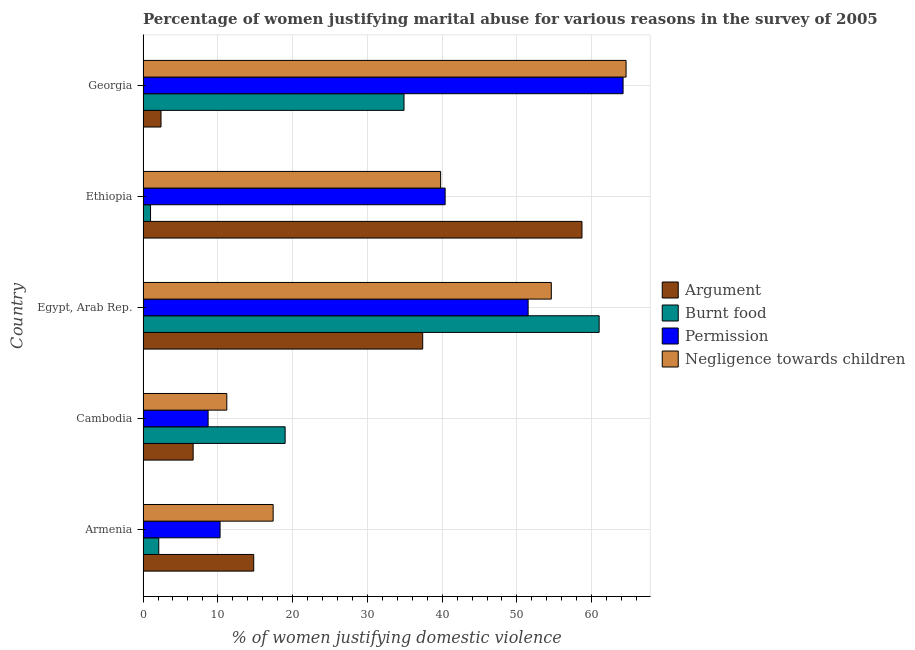How many different coloured bars are there?
Offer a very short reply. 4. What is the label of the 3rd group of bars from the top?
Make the answer very short. Egypt, Arab Rep. In how many cases, is the number of bars for a given country not equal to the number of legend labels?
Provide a succinct answer. 0. What is the percentage of women justifying abuse for showing negligence towards children in Ethiopia?
Offer a terse response. 39.8. Across all countries, what is the maximum percentage of women justifying abuse in the case of an argument?
Your response must be concise. 58.7. In which country was the percentage of women justifying abuse for going without permission maximum?
Provide a succinct answer. Georgia. In which country was the percentage of women justifying abuse in the case of an argument minimum?
Provide a short and direct response. Georgia. What is the total percentage of women justifying abuse for burning food in the graph?
Give a very brief answer. 118. What is the difference between the percentage of women justifying abuse for burning food in Armenia and that in Egypt, Arab Rep.?
Offer a terse response. -58.9. What is the difference between the percentage of women justifying abuse for showing negligence towards children in Ethiopia and the percentage of women justifying abuse in the case of an argument in Armenia?
Offer a terse response. 25. What is the average percentage of women justifying abuse for showing negligence towards children per country?
Provide a succinct answer. 37.52. What is the difference between the percentage of women justifying abuse for showing negligence towards children and percentage of women justifying abuse for going without permission in Cambodia?
Offer a very short reply. 2.5. In how many countries, is the percentage of women justifying abuse in the case of an argument greater than 62 %?
Provide a succinct answer. 0. What is the ratio of the percentage of women justifying abuse for burning food in Armenia to that in Cambodia?
Your answer should be very brief. 0.11. Is the percentage of women justifying abuse in the case of an argument in Armenia less than that in Ethiopia?
Ensure brevity in your answer.  Yes. Is the difference between the percentage of women justifying abuse for burning food in Ethiopia and Georgia greater than the difference between the percentage of women justifying abuse for showing negligence towards children in Ethiopia and Georgia?
Keep it short and to the point. No. What is the difference between the highest and the second highest percentage of women justifying abuse for going without permission?
Offer a very short reply. 12.7. What is the difference between the highest and the lowest percentage of women justifying abuse for going without permission?
Provide a short and direct response. 55.5. Is the sum of the percentage of women justifying abuse for going without permission in Egypt, Arab Rep. and Georgia greater than the maximum percentage of women justifying abuse for burning food across all countries?
Give a very brief answer. Yes. Is it the case that in every country, the sum of the percentage of women justifying abuse for burning food and percentage of women justifying abuse for showing negligence towards children is greater than the sum of percentage of women justifying abuse for going without permission and percentage of women justifying abuse in the case of an argument?
Offer a terse response. No. What does the 1st bar from the top in Cambodia represents?
Keep it short and to the point. Negligence towards children. What does the 2nd bar from the bottom in Egypt, Arab Rep. represents?
Your answer should be compact. Burnt food. Is it the case that in every country, the sum of the percentage of women justifying abuse in the case of an argument and percentage of women justifying abuse for burning food is greater than the percentage of women justifying abuse for going without permission?
Make the answer very short. No. How many countries are there in the graph?
Provide a short and direct response. 5. Are the values on the major ticks of X-axis written in scientific E-notation?
Your response must be concise. No. Does the graph contain grids?
Provide a short and direct response. Yes. What is the title of the graph?
Make the answer very short. Percentage of women justifying marital abuse for various reasons in the survey of 2005. What is the label or title of the X-axis?
Ensure brevity in your answer.  % of women justifying domestic violence. What is the % of women justifying domestic violence of Negligence towards children in Armenia?
Keep it short and to the point. 17.4. What is the % of women justifying domestic violence of Argument in Cambodia?
Offer a very short reply. 6.7. What is the % of women justifying domestic violence of Permission in Cambodia?
Keep it short and to the point. 8.7. What is the % of women justifying domestic violence of Negligence towards children in Cambodia?
Ensure brevity in your answer.  11.2. What is the % of women justifying domestic violence in Argument in Egypt, Arab Rep.?
Keep it short and to the point. 37.4. What is the % of women justifying domestic violence in Burnt food in Egypt, Arab Rep.?
Offer a terse response. 61. What is the % of women justifying domestic violence in Permission in Egypt, Arab Rep.?
Provide a succinct answer. 51.5. What is the % of women justifying domestic violence in Negligence towards children in Egypt, Arab Rep.?
Provide a succinct answer. 54.6. What is the % of women justifying domestic violence of Argument in Ethiopia?
Offer a terse response. 58.7. What is the % of women justifying domestic violence of Burnt food in Ethiopia?
Make the answer very short. 1. What is the % of women justifying domestic violence of Permission in Ethiopia?
Ensure brevity in your answer.  40.4. What is the % of women justifying domestic violence in Negligence towards children in Ethiopia?
Give a very brief answer. 39.8. What is the % of women justifying domestic violence of Argument in Georgia?
Provide a short and direct response. 2.4. What is the % of women justifying domestic violence of Burnt food in Georgia?
Provide a short and direct response. 34.9. What is the % of women justifying domestic violence in Permission in Georgia?
Keep it short and to the point. 64.2. What is the % of women justifying domestic violence of Negligence towards children in Georgia?
Your response must be concise. 64.6. Across all countries, what is the maximum % of women justifying domestic violence of Argument?
Ensure brevity in your answer.  58.7. Across all countries, what is the maximum % of women justifying domestic violence of Burnt food?
Give a very brief answer. 61. Across all countries, what is the maximum % of women justifying domestic violence in Permission?
Your response must be concise. 64.2. Across all countries, what is the maximum % of women justifying domestic violence in Negligence towards children?
Offer a very short reply. 64.6. Across all countries, what is the minimum % of women justifying domestic violence in Permission?
Your answer should be compact. 8.7. What is the total % of women justifying domestic violence in Argument in the graph?
Your response must be concise. 120. What is the total % of women justifying domestic violence of Burnt food in the graph?
Your response must be concise. 118. What is the total % of women justifying domestic violence of Permission in the graph?
Your answer should be very brief. 175.1. What is the total % of women justifying domestic violence of Negligence towards children in the graph?
Your response must be concise. 187.6. What is the difference between the % of women justifying domestic violence of Argument in Armenia and that in Cambodia?
Offer a very short reply. 8.1. What is the difference between the % of women justifying domestic violence of Burnt food in Armenia and that in Cambodia?
Ensure brevity in your answer.  -16.9. What is the difference between the % of women justifying domestic violence in Argument in Armenia and that in Egypt, Arab Rep.?
Give a very brief answer. -22.6. What is the difference between the % of women justifying domestic violence in Burnt food in Armenia and that in Egypt, Arab Rep.?
Your response must be concise. -58.9. What is the difference between the % of women justifying domestic violence of Permission in Armenia and that in Egypt, Arab Rep.?
Offer a terse response. -41.2. What is the difference between the % of women justifying domestic violence in Negligence towards children in Armenia and that in Egypt, Arab Rep.?
Ensure brevity in your answer.  -37.2. What is the difference between the % of women justifying domestic violence in Argument in Armenia and that in Ethiopia?
Provide a succinct answer. -43.9. What is the difference between the % of women justifying domestic violence in Permission in Armenia and that in Ethiopia?
Ensure brevity in your answer.  -30.1. What is the difference between the % of women justifying domestic violence in Negligence towards children in Armenia and that in Ethiopia?
Give a very brief answer. -22.4. What is the difference between the % of women justifying domestic violence in Burnt food in Armenia and that in Georgia?
Give a very brief answer. -32.8. What is the difference between the % of women justifying domestic violence in Permission in Armenia and that in Georgia?
Your answer should be very brief. -53.9. What is the difference between the % of women justifying domestic violence in Negligence towards children in Armenia and that in Georgia?
Offer a very short reply. -47.2. What is the difference between the % of women justifying domestic violence of Argument in Cambodia and that in Egypt, Arab Rep.?
Ensure brevity in your answer.  -30.7. What is the difference between the % of women justifying domestic violence in Burnt food in Cambodia and that in Egypt, Arab Rep.?
Your answer should be very brief. -42. What is the difference between the % of women justifying domestic violence in Permission in Cambodia and that in Egypt, Arab Rep.?
Give a very brief answer. -42.8. What is the difference between the % of women justifying domestic violence of Negligence towards children in Cambodia and that in Egypt, Arab Rep.?
Give a very brief answer. -43.4. What is the difference between the % of women justifying domestic violence in Argument in Cambodia and that in Ethiopia?
Your response must be concise. -52. What is the difference between the % of women justifying domestic violence of Permission in Cambodia and that in Ethiopia?
Provide a succinct answer. -31.7. What is the difference between the % of women justifying domestic violence of Negligence towards children in Cambodia and that in Ethiopia?
Provide a succinct answer. -28.6. What is the difference between the % of women justifying domestic violence of Argument in Cambodia and that in Georgia?
Keep it short and to the point. 4.3. What is the difference between the % of women justifying domestic violence in Burnt food in Cambodia and that in Georgia?
Provide a short and direct response. -15.9. What is the difference between the % of women justifying domestic violence of Permission in Cambodia and that in Georgia?
Ensure brevity in your answer.  -55.5. What is the difference between the % of women justifying domestic violence in Negligence towards children in Cambodia and that in Georgia?
Your answer should be very brief. -53.4. What is the difference between the % of women justifying domestic violence of Argument in Egypt, Arab Rep. and that in Ethiopia?
Ensure brevity in your answer.  -21.3. What is the difference between the % of women justifying domestic violence in Negligence towards children in Egypt, Arab Rep. and that in Ethiopia?
Offer a very short reply. 14.8. What is the difference between the % of women justifying domestic violence of Burnt food in Egypt, Arab Rep. and that in Georgia?
Offer a terse response. 26.1. What is the difference between the % of women justifying domestic violence of Permission in Egypt, Arab Rep. and that in Georgia?
Your response must be concise. -12.7. What is the difference between the % of women justifying domestic violence of Argument in Ethiopia and that in Georgia?
Your answer should be very brief. 56.3. What is the difference between the % of women justifying domestic violence of Burnt food in Ethiopia and that in Georgia?
Your response must be concise. -33.9. What is the difference between the % of women justifying domestic violence in Permission in Ethiopia and that in Georgia?
Provide a short and direct response. -23.8. What is the difference between the % of women justifying domestic violence in Negligence towards children in Ethiopia and that in Georgia?
Your answer should be compact. -24.8. What is the difference between the % of women justifying domestic violence in Argument in Armenia and the % of women justifying domestic violence in Permission in Cambodia?
Make the answer very short. 6.1. What is the difference between the % of women justifying domestic violence in Argument in Armenia and the % of women justifying domestic violence in Negligence towards children in Cambodia?
Your response must be concise. 3.6. What is the difference between the % of women justifying domestic violence in Burnt food in Armenia and the % of women justifying domestic violence in Permission in Cambodia?
Provide a short and direct response. -6.6. What is the difference between the % of women justifying domestic violence in Permission in Armenia and the % of women justifying domestic violence in Negligence towards children in Cambodia?
Offer a terse response. -0.9. What is the difference between the % of women justifying domestic violence in Argument in Armenia and the % of women justifying domestic violence in Burnt food in Egypt, Arab Rep.?
Offer a very short reply. -46.2. What is the difference between the % of women justifying domestic violence in Argument in Armenia and the % of women justifying domestic violence in Permission in Egypt, Arab Rep.?
Offer a very short reply. -36.7. What is the difference between the % of women justifying domestic violence in Argument in Armenia and the % of women justifying domestic violence in Negligence towards children in Egypt, Arab Rep.?
Provide a succinct answer. -39.8. What is the difference between the % of women justifying domestic violence of Burnt food in Armenia and the % of women justifying domestic violence of Permission in Egypt, Arab Rep.?
Keep it short and to the point. -49.4. What is the difference between the % of women justifying domestic violence in Burnt food in Armenia and the % of women justifying domestic violence in Negligence towards children in Egypt, Arab Rep.?
Keep it short and to the point. -52.5. What is the difference between the % of women justifying domestic violence in Permission in Armenia and the % of women justifying domestic violence in Negligence towards children in Egypt, Arab Rep.?
Provide a succinct answer. -44.3. What is the difference between the % of women justifying domestic violence in Argument in Armenia and the % of women justifying domestic violence in Permission in Ethiopia?
Give a very brief answer. -25.6. What is the difference between the % of women justifying domestic violence in Burnt food in Armenia and the % of women justifying domestic violence in Permission in Ethiopia?
Provide a short and direct response. -38.3. What is the difference between the % of women justifying domestic violence of Burnt food in Armenia and the % of women justifying domestic violence of Negligence towards children in Ethiopia?
Give a very brief answer. -37.7. What is the difference between the % of women justifying domestic violence in Permission in Armenia and the % of women justifying domestic violence in Negligence towards children in Ethiopia?
Provide a succinct answer. -29.5. What is the difference between the % of women justifying domestic violence of Argument in Armenia and the % of women justifying domestic violence of Burnt food in Georgia?
Make the answer very short. -20.1. What is the difference between the % of women justifying domestic violence in Argument in Armenia and the % of women justifying domestic violence in Permission in Georgia?
Your answer should be compact. -49.4. What is the difference between the % of women justifying domestic violence in Argument in Armenia and the % of women justifying domestic violence in Negligence towards children in Georgia?
Give a very brief answer. -49.8. What is the difference between the % of women justifying domestic violence of Burnt food in Armenia and the % of women justifying domestic violence of Permission in Georgia?
Make the answer very short. -62.1. What is the difference between the % of women justifying domestic violence in Burnt food in Armenia and the % of women justifying domestic violence in Negligence towards children in Georgia?
Make the answer very short. -62.5. What is the difference between the % of women justifying domestic violence of Permission in Armenia and the % of women justifying domestic violence of Negligence towards children in Georgia?
Provide a succinct answer. -54.3. What is the difference between the % of women justifying domestic violence in Argument in Cambodia and the % of women justifying domestic violence in Burnt food in Egypt, Arab Rep.?
Your answer should be compact. -54.3. What is the difference between the % of women justifying domestic violence in Argument in Cambodia and the % of women justifying domestic violence in Permission in Egypt, Arab Rep.?
Provide a short and direct response. -44.8. What is the difference between the % of women justifying domestic violence of Argument in Cambodia and the % of women justifying domestic violence of Negligence towards children in Egypt, Arab Rep.?
Your answer should be compact. -47.9. What is the difference between the % of women justifying domestic violence of Burnt food in Cambodia and the % of women justifying domestic violence of Permission in Egypt, Arab Rep.?
Offer a terse response. -32.5. What is the difference between the % of women justifying domestic violence of Burnt food in Cambodia and the % of women justifying domestic violence of Negligence towards children in Egypt, Arab Rep.?
Offer a terse response. -35.6. What is the difference between the % of women justifying domestic violence of Permission in Cambodia and the % of women justifying domestic violence of Negligence towards children in Egypt, Arab Rep.?
Your response must be concise. -45.9. What is the difference between the % of women justifying domestic violence of Argument in Cambodia and the % of women justifying domestic violence of Burnt food in Ethiopia?
Give a very brief answer. 5.7. What is the difference between the % of women justifying domestic violence of Argument in Cambodia and the % of women justifying domestic violence of Permission in Ethiopia?
Make the answer very short. -33.7. What is the difference between the % of women justifying domestic violence of Argument in Cambodia and the % of women justifying domestic violence of Negligence towards children in Ethiopia?
Your answer should be very brief. -33.1. What is the difference between the % of women justifying domestic violence in Burnt food in Cambodia and the % of women justifying domestic violence in Permission in Ethiopia?
Your answer should be compact. -21.4. What is the difference between the % of women justifying domestic violence of Burnt food in Cambodia and the % of women justifying domestic violence of Negligence towards children in Ethiopia?
Your answer should be compact. -20.8. What is the difference between the % of women justifying domestic violence of Permission in Cambodia and the % of women justifying domestic violence of Negligence towards children in Ethiopia?
Keep it short and to the point. -31.1. What is the difference between the % of women justifying domestic violence of Argument in Cambodia and the % of women justifying domestic violence of Burnt food in Georgia?
Give a very brief answer. -28.2. What is the difference between the % of women justifying domestic violence of Argument in Cambodia and the % of women justifying domestic violence of Permission in Georgia?
Make the answer very short. -57.5. What is the difference between the % of women justifying domestic violence of Argument in Cambodia and the % of women justifying domestic violence of Negligence towards children in Georgia?
Your answer should be compact. -57.9. What is the difference between the % of women justifying domestic violence in Burnt food in Cambodia and the % of women justifying domestic violence in Permission in Georgia?
Your answer should be compact. -45.2. What is the difference between the % of women justifying domestic violence in Burnt food in Cambodia and the % of women justifying domestic violence in Negligence towards children in Georgia?
Provide a short and direct response. -45.6. What is the difference between the % of women justifying domestic violence of Permission in Cambodia and the % of women justifying domestic violence of Negligence towards children in Georgia?
Give a very brief answer. -55.9. What is the difference between the % of women justifying domestic violence of Argument in Egypt, Arab Rep. and the % of women justifying domestic violence of Burnt food in Ethiopia?
Offer a very short reply. 36.4. What is the difference between the % of women justifying domestic violence of Argument in Egypt, Arab Rep. and the % of women justifying domestic violence of Permission in Ethiopia?
Keep it short and to the point. -3. What is the difference between the % of women justifying domestic violence in Argument in Egypt, Arab Rep. and the % of women justifying domestic violence in Negligence towards children in Ethiopia?
Make the answer very short. -2.4. What is the difference between the % of women justifying domestic violence in Burnt food in Egypt, Arab Rep. and the % of women justifying domestic violence in Permission in Ethiopia?
Offer a terse response. 20.6. What is the difference between the % of women justifying domestic violence in Burnt food in Egypt, Arab Rep. and the % of women justifying domestic violence in Negligence towards children in Ethiopia?
Make the answer very short. 21.2. What is the difference between the % of women justifying domestic violence of Permission in Egypt, Arab Rep. and the % of women justifying domestic violence of Negligence towards children in Ethiopia?
Keep it short and to the point. 11.7. What is the difference between the % of women justifying domestic violence of Argument in Egypt, Arab Rep. and the % of women justifying domestic violence of Permission in Georgia?
Offer a very short reply. -26.8. What is the difference between the % of women justifying domestic violence of Argument in Egypt, Arab Rep. and the % of women justifying domestic violence of Negligence towards children in Georgia?
Provide a short and direct response. -27.2. What is the difference between the % of women justifying domestic violence in Burnt food in Egypt, Arab Rep. and the % of women justifying domestic violence in Permission in Georgia?
Offer a terse response. -3.2. What is the difference between the % of women justifying domestic violence of Burnt food in Egypt, Arab Rep. and the % of women justifying domestic violence of Negligence towards children in Georgia?
Make the answer very short. -3.6. What is the difference between the % of women justifying domestic violence in Permission in Egypt, Arab Rep. and the % of women justifying domestic violence in Negligence towards children in Georgia?
Your answer should be very brief. -13.1. What is the difference between the % of women justifying domestic violence of Argument in Ethiopia and the % of women justifying domestic violence of Burnt food in Georgia?
Keep it short and to the point. 23.8. What is the difference between the % of women justifying domestic violence in Argument in Ethiopia and the % of women justifying domestic violence in Negligence towards children in Georgia?
Your answer should be compact. -5.9. What is the difference between the % of women justifying domestic violence in Burnt food in Ethiopia and the % of women justifying domestic violence in Permission in Georgia?
Your answer should be very brief. -63.2. What is the difference between the % of women justifying domestic violence of Burnt food in Ethiopia and the % of women justifying domestic violence of Negligence towards children in Georgia?
Keep it short and to the point. -63.6. What is the difference between the % of women justifying domestic violence of Permission in Ethiopia and the % of women justifying domestic violence of Negligence towards children in Georgia?
Your answer should be very brief. -24.2. What is the average % of women justifying domestic violence in Argument per country?
Your answer should be very brief. 24. What is the average % of women justifying domestic violence in Burnt food per country?
Keep it short and to the point. 23.6. What is the average % of women justifying domestic violence of Permission per country?
Ensure brevity in your answer.  35.02. What is the average % of women justifying domestic violence of Negligence towards children per country?
Give a very brief answer. 37.52. What is the difference between the % of women justifying domestic violence of Argument and % of women justifying domestic violence of Burnt food in Armenia?
Your answer should be very brief. 12.7. What is the difference between the % of women justifying domestic violence in Argument and % of women justifying domestic violence in Permission in Armenia?
Provide a succinct answer. 4.5. What is the difference between the % of women justifying domestic violence in Burnt food and % of women justifying domestic violence in Permission in Armenia?
Your response must be concise. -8.2. What is the difference between the % of women justifying domestic violence of Burnt food and % of women justifying domestic violence of Negligence towards children in Armenia?
Offer a terse response. -15.3. What is the difference between the % of women justifying domestic violence in Argument and % of women justifying domestic violence in Burnt food in Cambodia?
Your response must be concise. -12.3. What is the difference between the % of women justifying domestic violence of Argument and % of women justifying domestic violence of Permission in Cambodia?
Provide a short and direct response. -2. What is the difference between the % of women justifying domestic violence of Argument and % of women justifying domestic violence of Negligence towards children in Cambodia?
Give a very brief answer. -4.5. What is the difference between the % of women justifying domestic violence of Burnt food and % of women justifying domestic violence of Permission in Cambodia?
Give a very brief answer. 10.3. What is the difference between the % of women justifying domestic violence of Burnt food and % of women justifying domestic violence of Negligence towards children in Cambodia?
Offer a terse response. 7.8. What is the difference between the % of women justifying domestic violence of Permission and % of women justifying domestic violence of Negligence towards children in Cambodia?
Keep it short and to the point. -2.5. What is the difference between the % of women justifying domestic violence in Argument and % of women justifying domestic violence in Burnt food in Egypt, Arab Rep.?
Your response must be concise. -23.6. What is the difference between the % of women justifying domestic violence in Argument and % of women justifying domestic violence in Permission in Egypt, Arab Rep.?
Ensure brevity in your answer.  -14.1. What is the difference between the % of women justifying domestic violence of Argument and % of women justifying domestic violence of Negligence towards children in Egypt, Arab Rep.?
Your answer should be compact. -17.2. What is the difference between the % of women justifying domestic violence of Burnt food and % of women justifying domestic violence of Permission in Egypt, Arab Rep.?
Give a very brief answer. 9.5. What is the difference between the % of women justifying domestic violence of Argument and % of women justifying domestic violence of Burnt food in Ethiopia?
Give a very brief answer. 57.7. What is the difference between the % of women justifying domestic violence of Argument and % of women justifying domestic violence of Permission in Ethiopia?
Your answer should be compact. 18.3. What is the difference between the % of women justifying domestic violence of Argument and % of women justifying domestic violence of Negligence towards children in Ethiopia?
Provide a succinct answer. 18.9. What is the difference between the % of women justifying domestic violence in Burnt food and % of women justifying domestic violence in Permission in Ethiopia?
Offer a very short reply. -39.4. What is the difference between the % of women justifying domestic violence in Burnt food and % of women justifying domestic violence in Negligence towards children in Ethiopia?
Ensure brevity in your answer.  -38.8. What is the difference between the % of women justifying domestic violence in Argument and % of women justifying domestic violence in Burnt food in Georgia?
Keep it short and to the point. -32.5. What is the difference between the % of women justifying domestic violence in Argument and % of women justifying domestic violence in Permission in Georgia?
Your response must be concise. -61.8. What is the difference between the % of women justifying domestic violence in Argument and % of women justifying domestic violence in Negligence towards children in Georgia?
Offer a terse response. -62.2. What is the difference between the % of women justifying domestic violence of Burnt food and % of women justifying domestic violence of Permission in Georgia?
Your answer should be compact. -29.3. What is the difference between the % of women justifying domestic violence in Burnt food and % of women justifying domestic violence in Negligence towards children in Georgia?
Offer a terse response. -29.7. What is the difference between the % of women justifying domestic violence in Permission and % of women justifying domestic violence in Negligence towards children in Georgia?
Your response must be concise. -0.4. What is the ratio of the % of women justifying domestic violence of Argument in Armenia to that in Cambodia?
Give a very brief answer. 2.21. What is the ratio of the % of women justifying domestic violence in Burnt food in Armenia to that in Cambodia?
Your response must be concise. 0.11. What is the ratio of the % of women justifying domestic violence of Permission in Armenia to that in Cambodia?
Give a very brief answer. 1.18. What is the ratio of the % of women justifying domestic violence in Negligence towards children in Armenia to that in Cambodia?
Ensure brevity in your answer.  1.55. What is the ratio of the % of women justifying domestic violence in Argument in Armenia to that in Egypt, Arab Rep.?
Keep it short and to the point. 0.4. What is the ratio of the % of women justifying domestic violence in Burnt food in Armenia to that in Egypt, Arab Rep.?
Your answer should be compact. 0.03. What is the ratio of the % of women justifying domestic violence of Negligence towards children in Armenia to that in Egypt, Arab Rep.?
Give a very brief answer. 0.32. What is the ratio of the % of women justifying domestic violence in Argument in Armenia to that in Ethiopia?
Ensure brevity in your answer.  0.25. What is the ratio of the % of women justifying domestic violence of Burnt food in Armenia to that in Ethiopia?
Ensure brevity in your answer.  2.1. What is the ratio of the % of women justifying domestic violence in Permission in Armenia to that in Ethiopia?
Provide a short and direct response. 0.26. What is the ratio of the % of women justifying domestic violence in Negligence towards children in Armenia to that in Ethiopia?
Provide a succinct answer. 0.44. What is the ratio of the % of women justifying domestic violence in Argument in Armenia to that in Georgia?
Provide a succinct answer. 6.17. What is the ratio of the % of women justifying domestic violence in Burnt food in Armenia to that in Georgia?
Your answer should be compact. 0.06. What is the ratio of the % of women justifying domestic violence in Permission in Armenia to that in Georgia?
Make the answer very short. 0.16. What is the ratio of the % of women justifying domestic violence of Negligence towards children in Armenia to that in Georgia?
Your response must be concise. 0.27. What is the ratio of the % of women justifying domestic violence in Argument in Cambodia to that in Egypt, Arab Rep.?
Your response must be concise. 0.18. What is the ratio of the % of women justifying domestic violence in Burnt food in Cambodia to that in Egypt, Arab Rep.?
Give a very brief answer. 0.31. What is the ratio of the % of women justifying domestic violence in Permission in Cambodia to that in Egypt, Arab Rep.?
Your answer should be very brief. 0.17. What is the ratio of the % of women justifying domestic violence of Negligence towards children in Cambodia to that in Egypt, Arab Rep.?
Your answer should be compact. 0.21. What is the ratio of the % of women justifying domestic violence of Argument in Cambodia to that in Ethiopia?
Offer a terse response. 0.11. What is the ratio of the % of women justifying domestic violence in Permission in Cambodia to that in Ethiopia?
Your answer should be very brief. 0.22. What is the ratio of the % of women justifying domestic violence in Negligence towards children in Cambodia to that in Ethiopia?
Offer a terse response. 0.28. What is the ratio of the % of women justifying domestic violence in Argument in Cambodia to that in Georgia?
Provide a short and direct response. 2.79. What is the ratio of the % of women justifying domestic violence of Burnt food in Cambodia to that in Georgia?
Make the answer very short. 0.54. What is the ratio of the % of women justifying domestic violence in Permission in Cambodia to that in Georgia?
Your answer should be compact. 0.14. What is the ratio of the % of women justifying domestic violence in Negligence towards children in Cambodia to that in Georgia?
Your answer should be compact. 0.17. What is the ratio of the % of women justifying domestic violence in Argument in Egypt, Arab Rep. to that in Ethiopia?
Provide a succinct answer. 0.64. What is the ratio of the % of women justifying domestic violence of Permission in Egypt, Arab Rep. to that in Ethiopia?
Give a very brief answer. 1.27. What is the ratio of the % of women justifying domestic violence in Negligence towards children in Egypt, Arab Rep. to that in Ethiopia?
Make the answer very short. 1.37. What is the ratio of the % of women justifying domestic violence of Argument in Egypt, Arab Rep. to that in Georgia?
Provide a succinct answer. 15.58. What is the ratio of the % of women justifying domestic violence of Burnt food in Egypt, Arab Rep. to that in Georgia?
Give a very brief answer. 1.75. What is the ratio of the % of women justifying domestic violence of Permission in Egypt, Arab Rep. to that in Georgia?
Make the answer very short. 0.8. What is the ratio of the % of women justifying domestic violence in Negligence towards children in Egypt, Arab Rep. to that in Georgia?
Provide a short and direct response. 0.85. What is the ratio of the % of women justifying domestic violence in Argument in Ethiopia to that in Georgia?
Your answer should be very brief. 24.46. What is the ratio of the % of women justifying domestic violence in Burnt food in Ethiopia to that in Georgia?
Your response must be concise. 0.03. What is the ratio of the % of women justifying domestic violence of Permission in Ethiopia to that in Georgia?
Ensure brevity in your answer.  0.63. What is the ratio of the % of women justifying domestic violence in Negligence towards children in Ethiopia to that in Georgia?
Provide a succinct answer. 0.62. What is the difference between the highest and the second highest % of women justifying domestic violence in Argument?
Offer a terse response. 21.3. What is the difference between the highest and the second highest % of women justifying domestic violence in Burnt food?
Provide a short and direct response. 26.1. What is the difference between the highest and the second highest % of women justifying domestic violence of Permission?
Ensure brevity in your answer.  12.7. What is the difference between the highest and the lowest % of women justifying domestic violence of Argument?
Provide a short and direct response. 56.3. What is the difference between the highest and the lowest % of women justifying domestic violence of Permission?
Ensure brevity in your answer.  55.5. What is the difference between the highest and the lowest % of women justifying domestic violence in Negligence towards children?
Provide a succinct answer. 53.4. 